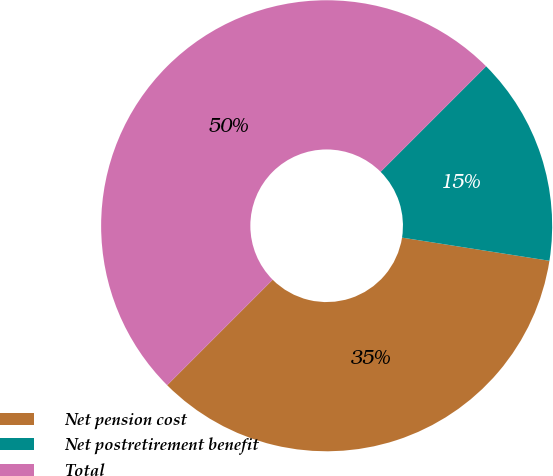Convert chart. <chart><loc_0><loc_0><loc_500><loc_500><pie_chart><fcel>Net pension cost<fcel>Net postretirement benefit<fcel>Total<nl><fcel>35.02%<fcel>14.98%<fcel>50.0%<nl></chart> 